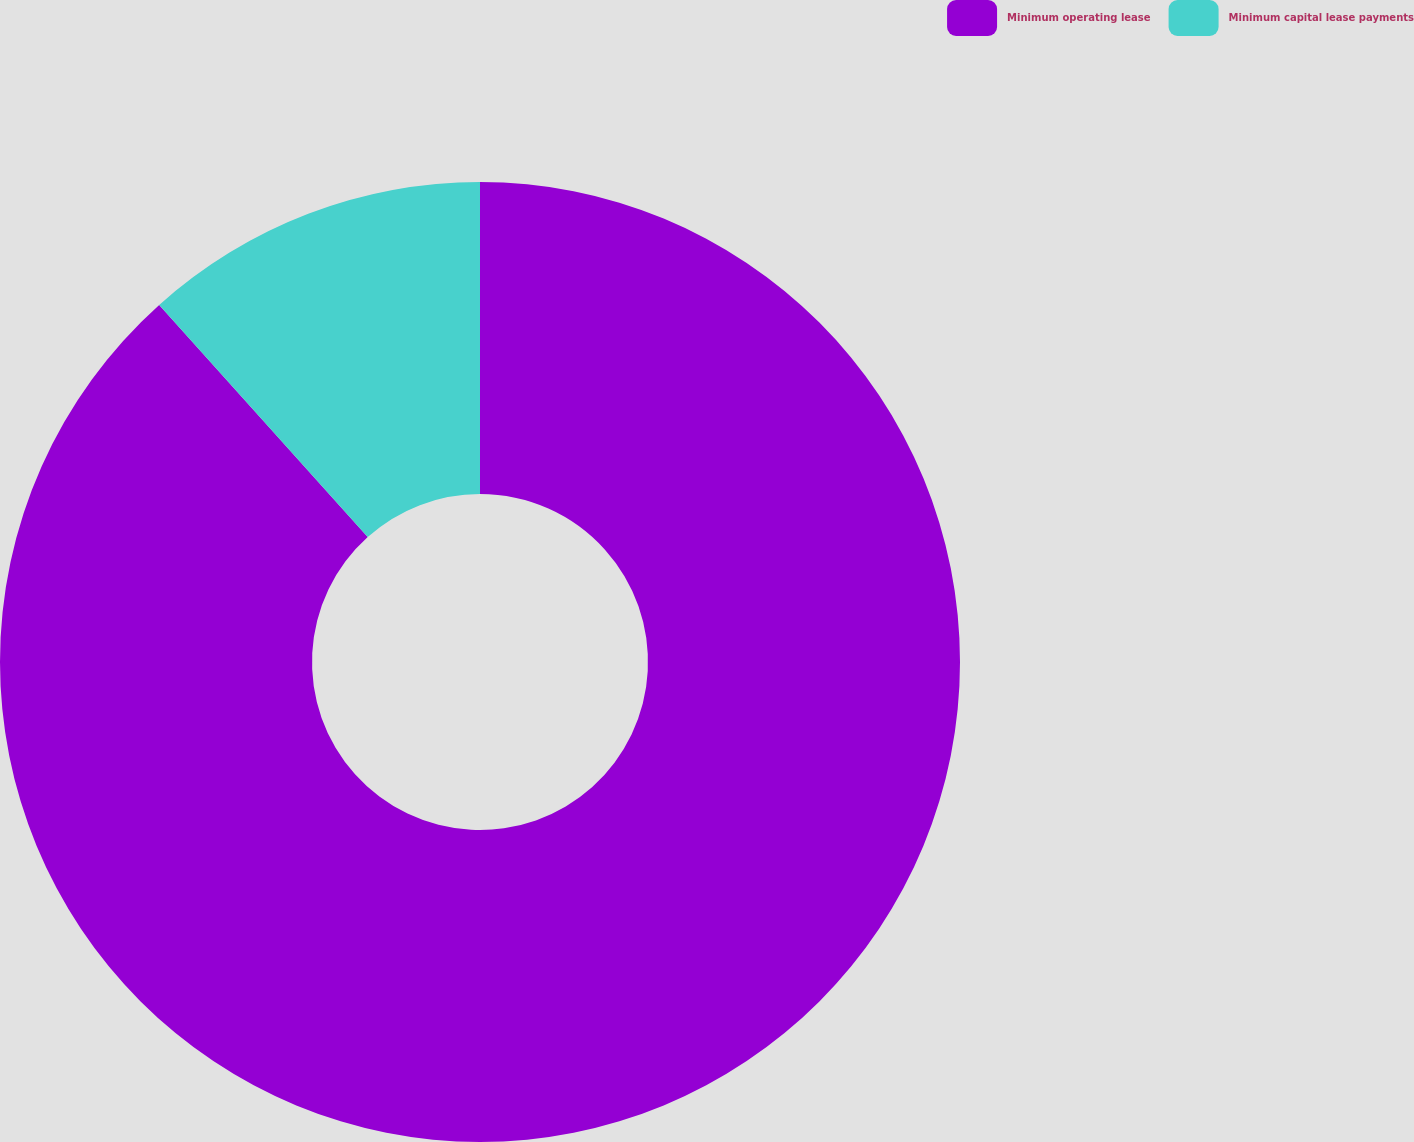<chart> <loc_0><loc_0><loc_500><loc_500><pie_chart><fcel>Minimum operating lease<fcel>Minimum capital lease payments<nl><fcel>88.35%<fcel>11.65%<nl></chart> 